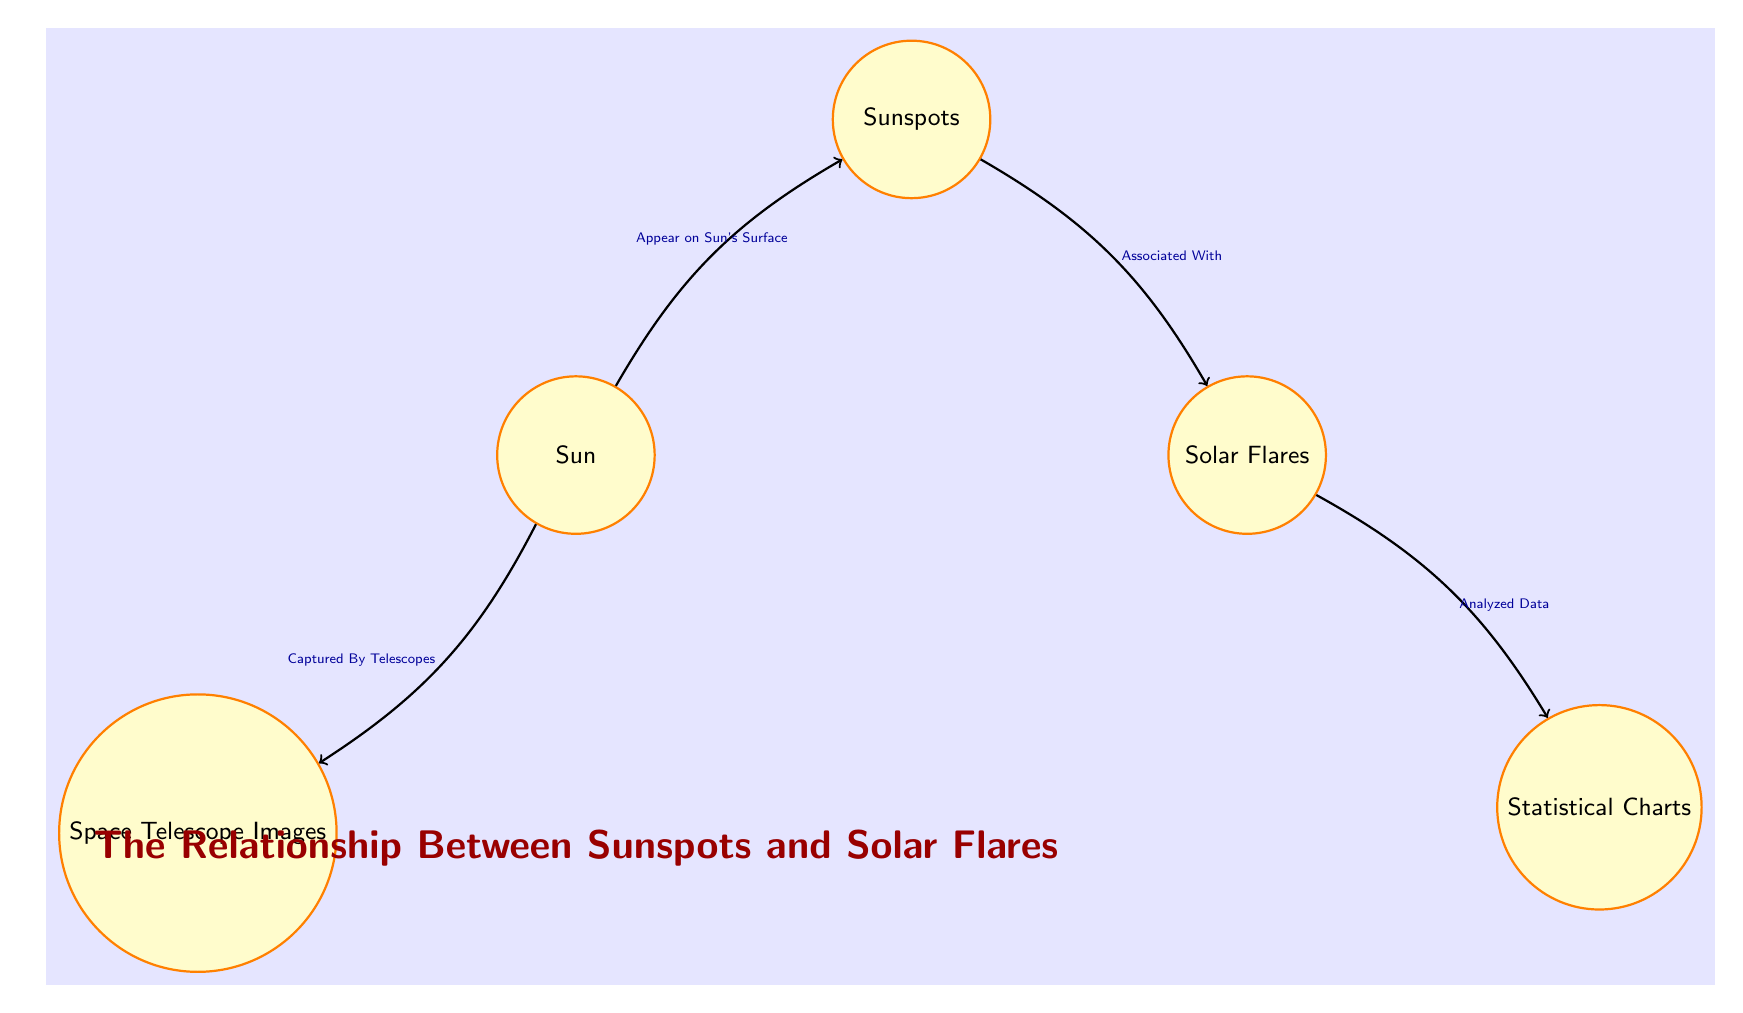What is depicted at the center of the diagram? The center of the diagram shows the "Sun," which is the focal point around which other elements are related, indicating its importance in the context of sunspots and solar flares.
Answer: Sun How many nodes are present in the diagram? The diagram includes five nodes: Sun, Sunspots, Solar Flares, Space Telescope Images, and Statistical Charts. Counting all of them gives a total of five.
Answer: 5 What do sunspots appear on? Sunspots are shown to "Appear on Sun's Surface," indicating that they are features specifically located on the surface of the Sun.
Answer: Sun's Surface What is the relationship between sunspots and solar flares? Sunspots are "Associated With" solar flares, indicating a correlation or connection between these two solar phenomena as depicted in the diagram.
Answer: Associated With Which node is analyzed to produce statistical data? The "Solar Flares" node is directly linked to "Statistical Charts," indicating that data regarding solar flares is analyzed to create these charts.
Answer: Solar Flares What evidence is captured from the sun? The diagram specifies that "Space Telescope Images" are captured from the Sun, implying that these images serve as observational data of solar phenomena.
Answer: Space Telescope Images What is the output of analyzing solar flares? Analyzing the data from solar flares results in "Statistical Charts," highlighting the importance of such analysis in representing information visually.
Answer: Statistical Charts Which element connects telescopes and the Sun? The diagram shows an edge from "Sun" to "Space Telescope Images" indicating that telescopes capture images of the sun.
Answer: Space Telescope Images 